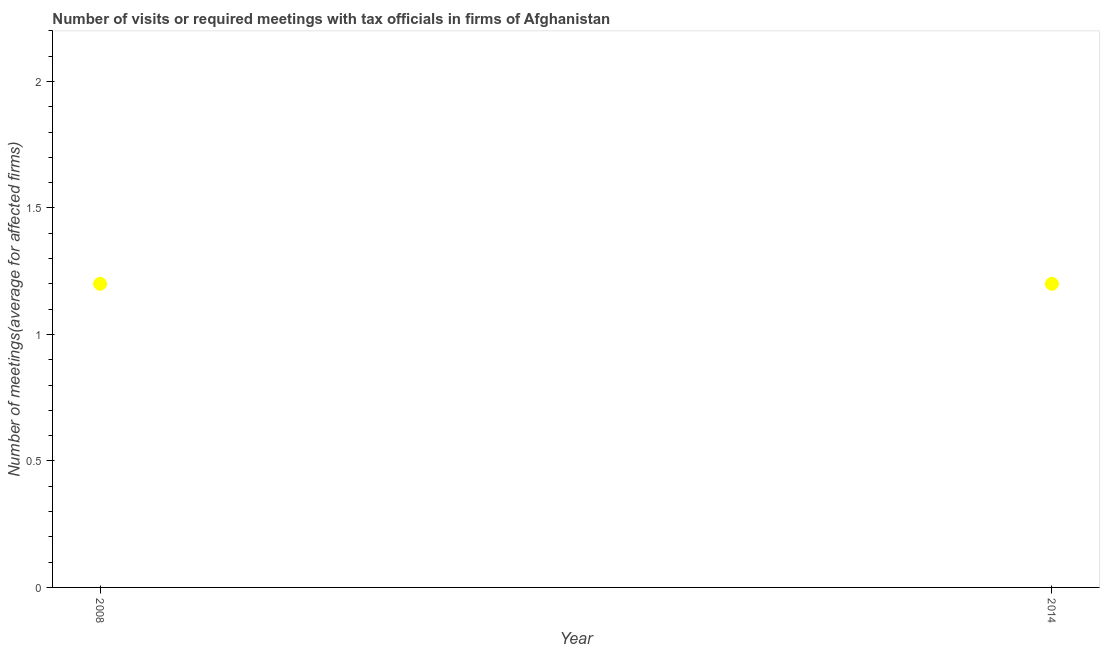What is the number of required meetings with tax officials in 2008?
Your answer should be very brief. 1.2. In which year was the number of required meetings with tax officials minimum?
Provide a short and direct response. 2008. What is the difference between the number of required meetings with tax officials in 2008 and 2014?
Make the answer very short. 0. What is the median number of required meetings with tax officials?
Keep it short and to the point. 1.2. Do a majority of the years between 2014 and 2008 (inclusive) have number of required meetings with tax officials greater than 0.8 ?
Provide a succinct answer. No. What is the ratio of the number of required meetings with tax officials in 2008 to that in 2014?
Offer a terse response. 1. Is the number of required meetings with tax officials in 2008 less than that in 2014?
Give a very brief answer. No. Does the number of required meetings with tax officials monotonically increase over the years?
Provide a succinct answer. No. How many dotlines are there?
Give a very brief answer. 1. How many years are there in the graph?
Provide a short and direct response. 2. What is the difference between two consecutive major ticks on the Y-axis?
Provide a short and direct response. 0.5. What is the title of the graph?
Give a very brief answer. Number of visits or required meetings with tax officials in firms of Afghanistan. What is the label or title of the Y-axis?
Offer a very short reply. Number of meetings(average for affected firms). What is the Number of meetings(average for affected firms) in 2014?
Offer a terse response. 1.2. What is the difference between the Number of meetings(average for affected firms) in 2008 and 2014?
Make the answer very short. 0. 